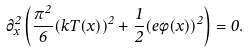<formula> <loc_0><loc_0><loc_500><loc_500>\partial _ { x } ^ { 2 } \left ( \frac { \pi ^ { 2 } } { 6 } ( k T ( x ) ) ^ { 2 } + \frac { 1 } { 2 } ( e \phi ( x ) ) ^ { 2 } \right ) = 0 .</formula> 